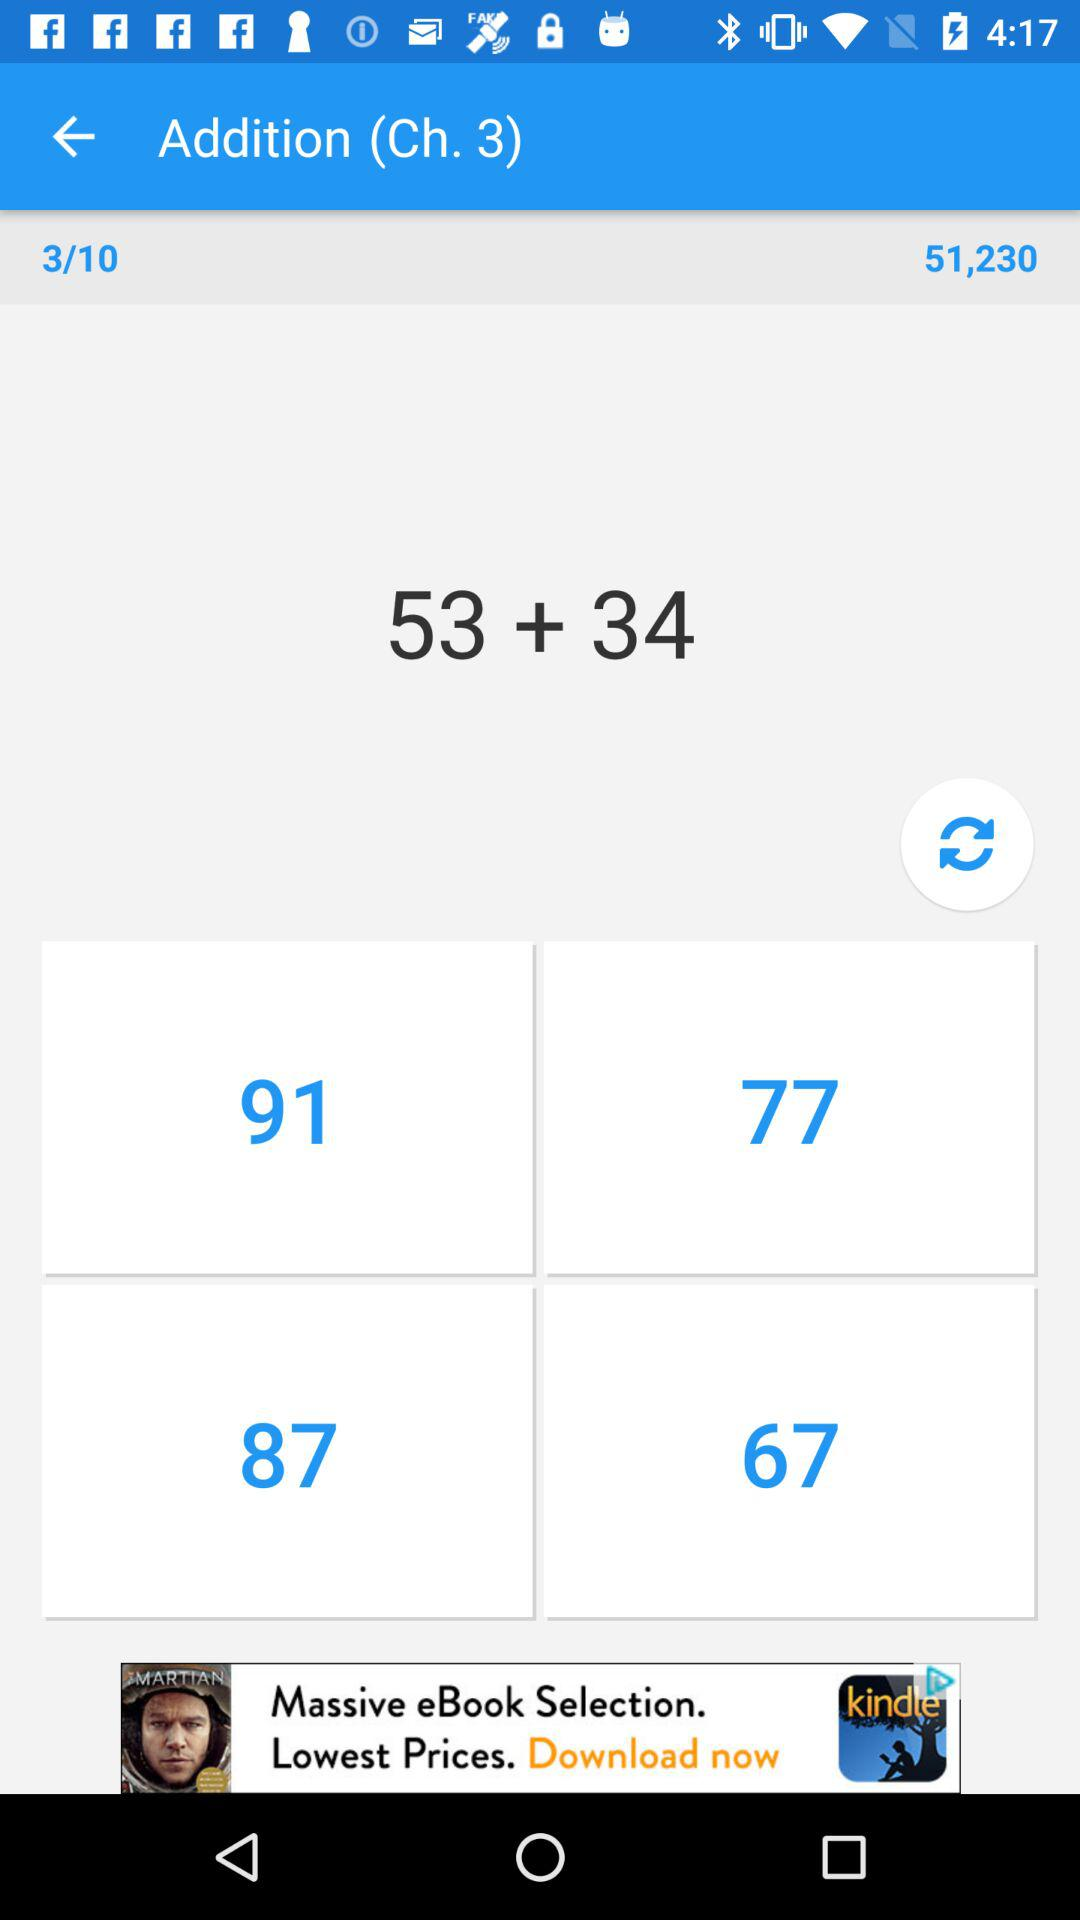What is the difference between the two numbers in the equation?
Answer the question using a single word or phrase. 19 